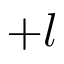<formula> <loc_0><loc_0><loc_500><loc_500>+ l</formula> 